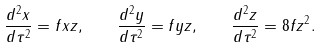Convert formula to latex. <formula><loc_0><loc_0><loc_500><loc_500>\frac { d ^ { 2 } x } { d \tau ^ { 2 } } = f x z , \quad \frac { d ^ { 2 } y } { d \tau ^ { 2 } } = f y z , \quad \frac { d ^ { 2 } z } { d \tau ^ { 2 } } = 8 f z ^ { 2 } .</formula> 